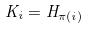<formula> <loc_0><loc_0><loc_500><loc_500>K _ { i } = H _ { \pi ( i ) }</formula> 